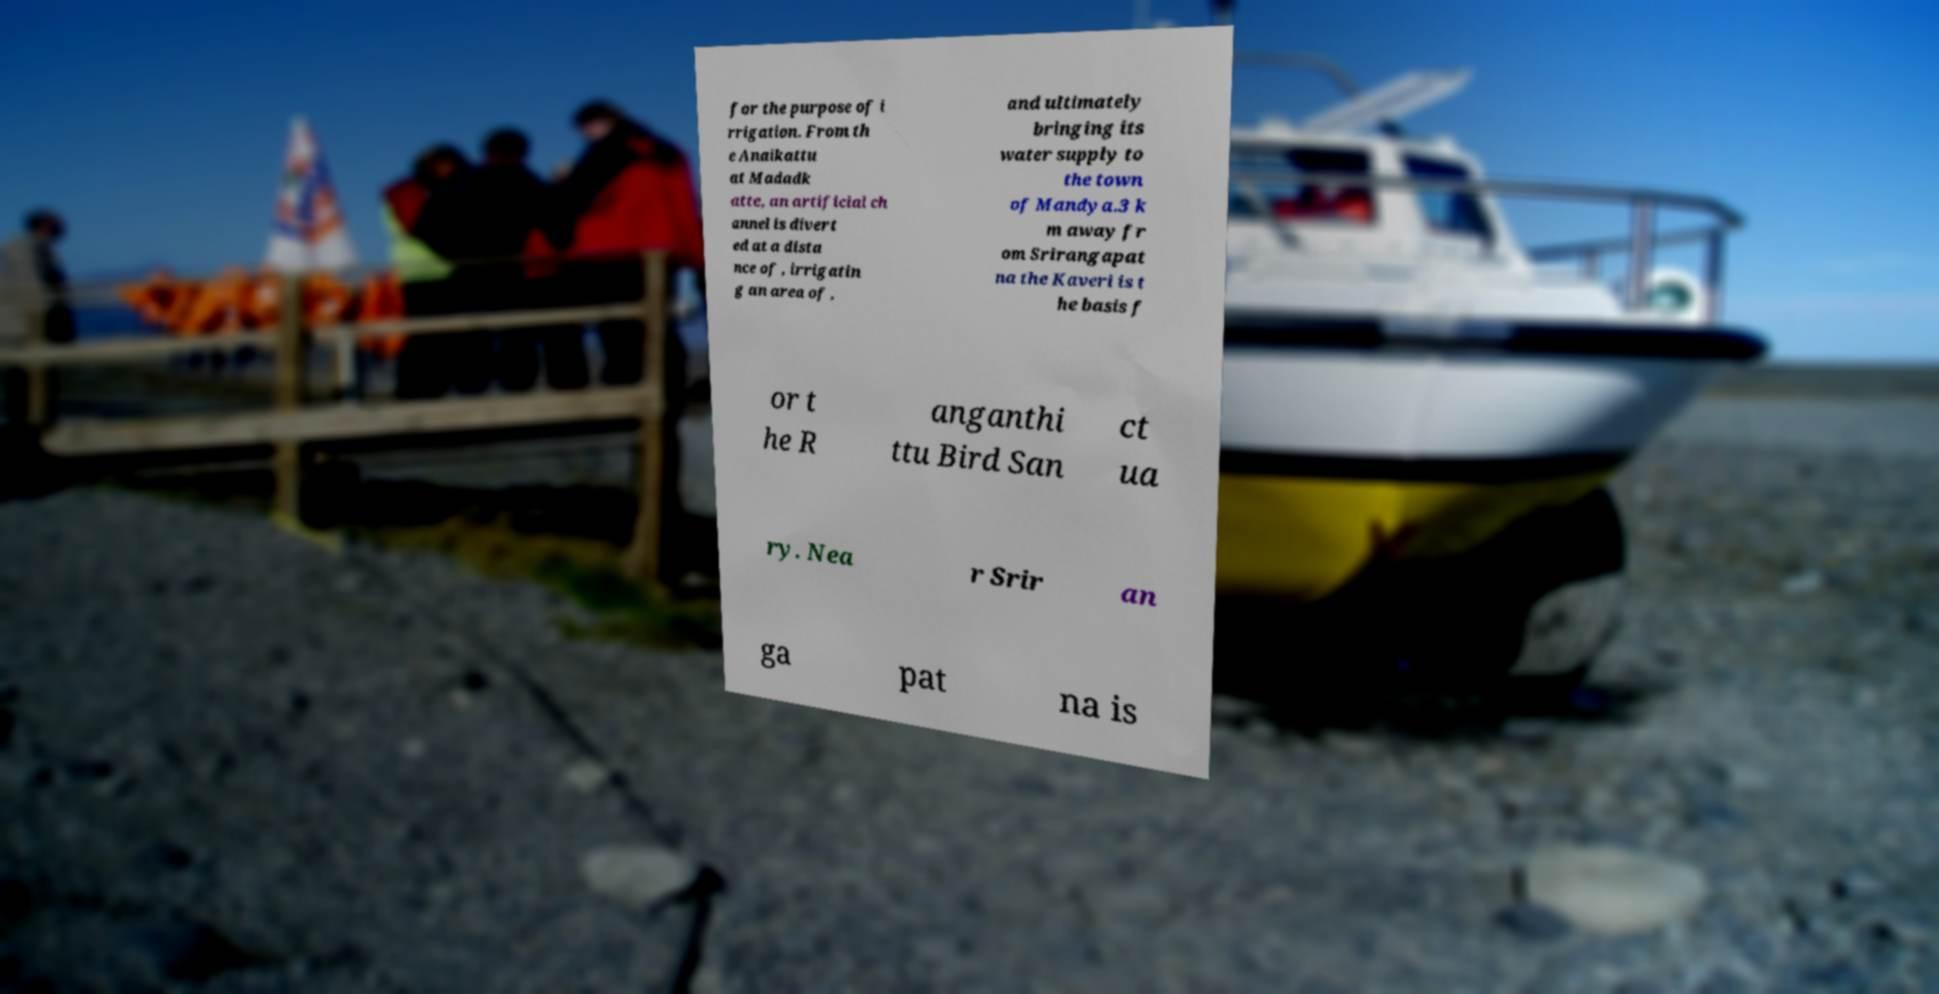Can you read and provide the text displayed in the image?This photo seems to have some interesting text. Can you extract and type it out for me? for the purpose of i rrigation. From th e Anaikattu at Madadk atte, an artificial ch annel is divert ed at a dista nce of , irrigatin g an area of , and ultimately bringing its water supply to the town of Mandya.3 k m away fr om Srirangapat na the Kaveri is t he basis f or t he R anganthi ttu Bird San ct ua ry. Nea r Srir an ga pat na is 